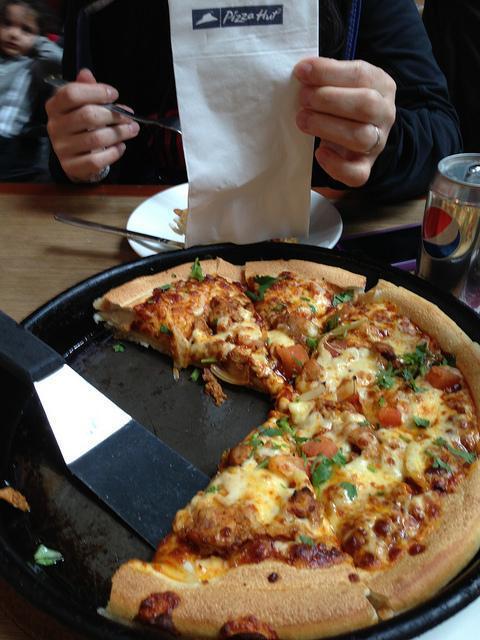How many pieces of pizza have already been eaten?
Give a very brief answer. 2. How many people are there?
Give a very brief answer. 2. 